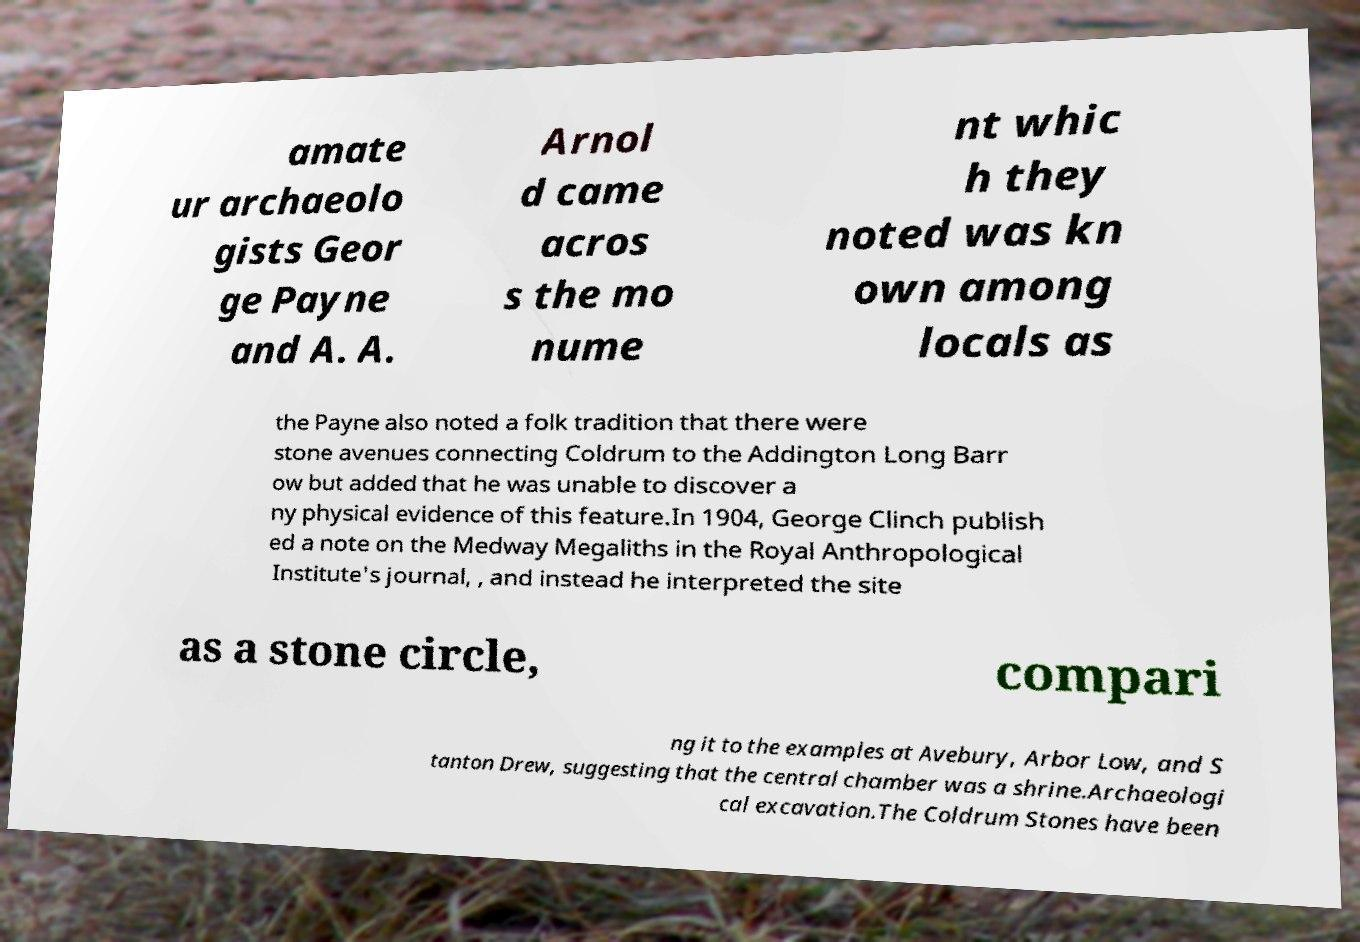Could you assist in decoding the text presented in this image and type it out clearly? amate ur archaeolo gists Geor ge Payne and A. A. Arnol d came acros s the mo nume nt whic h they noted was kn own among locals as the Payne also noted a folk tradition that there were stone avenues connecting Coldrum to the Addington Long Barr ow but added that he was unable to discover a ny physical evidence of this feature.In 1904, George Clinch publish ed a note on the Medway Megaliths in the Royal Anthropological Institute's journal, , and instead he interpreted the site as a stone circle, compari ng it to the examples at Avebury, Arbor Low, and S tanton Drew, suggesting that the central chamber was a shrine.Archaeologi cal excavation.The Coldrum Stones have been 